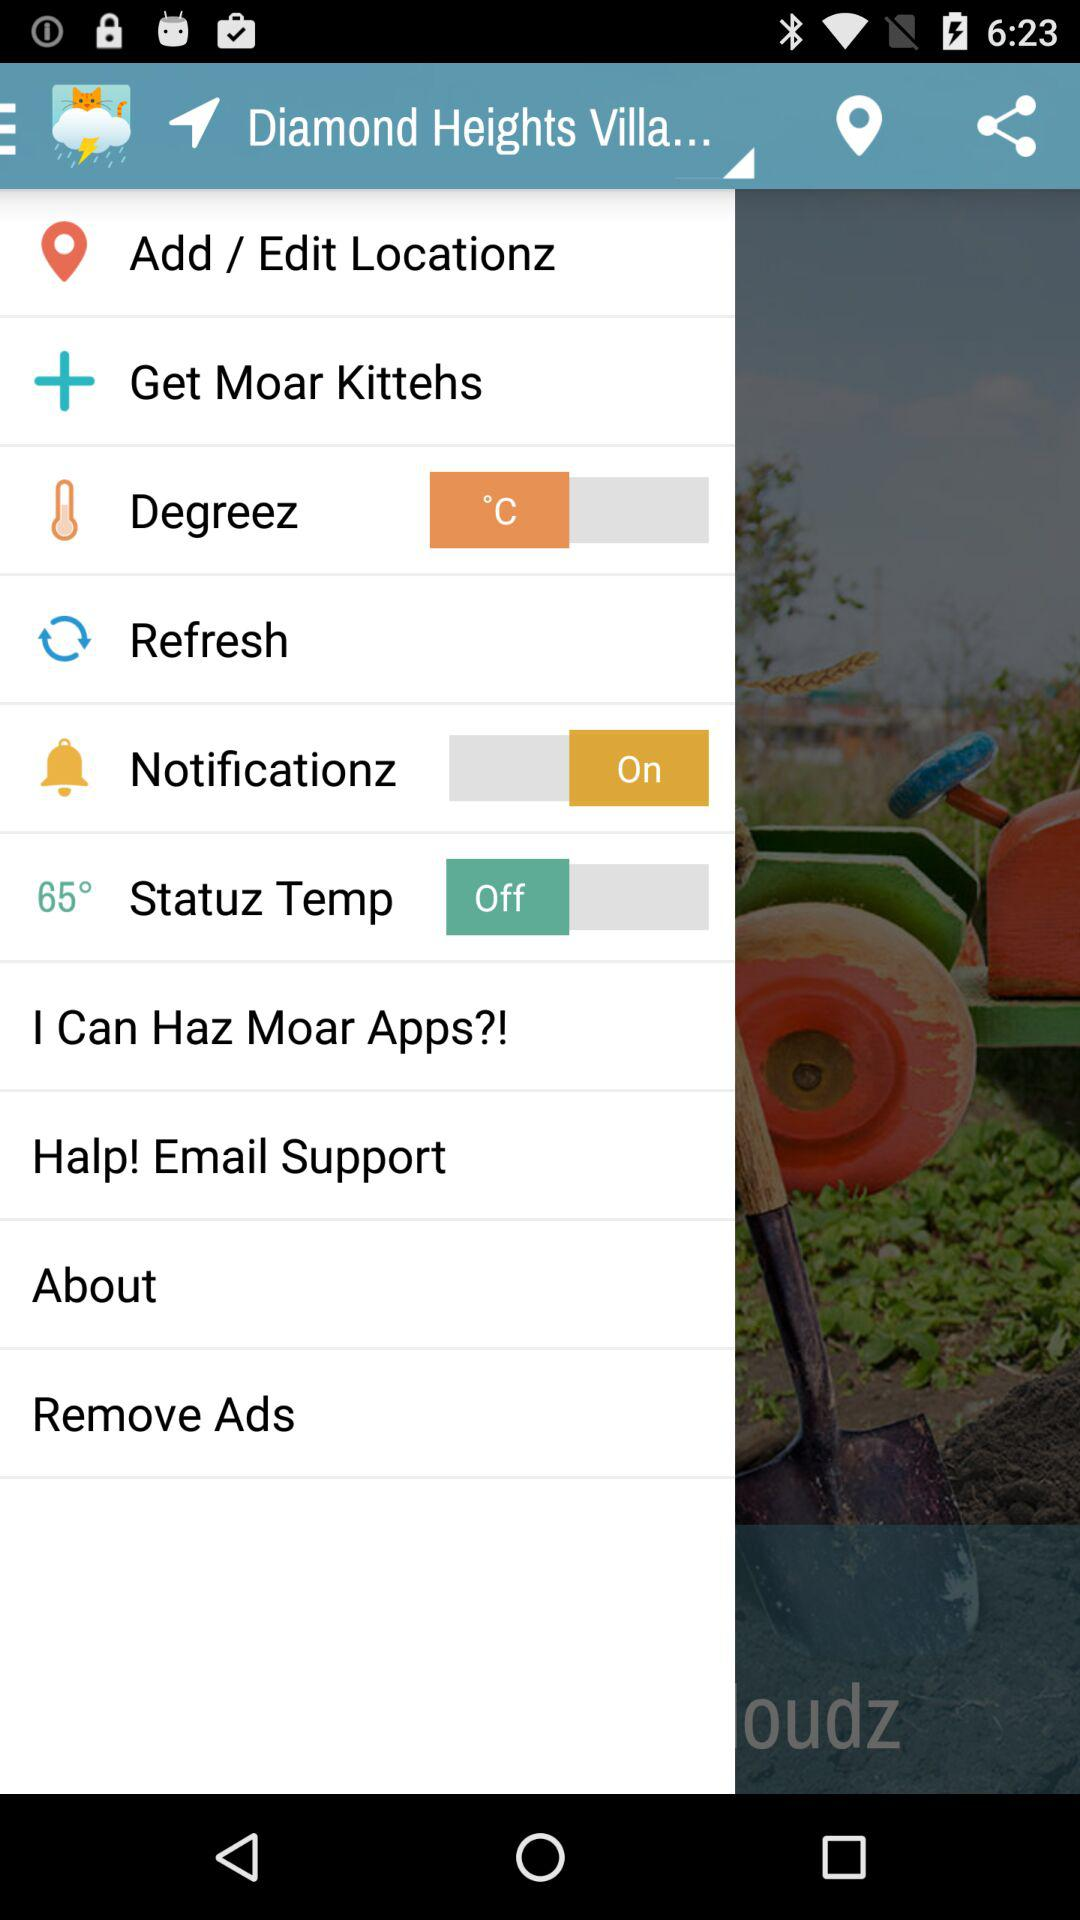What is the status of Notificationz? The status is "On". 